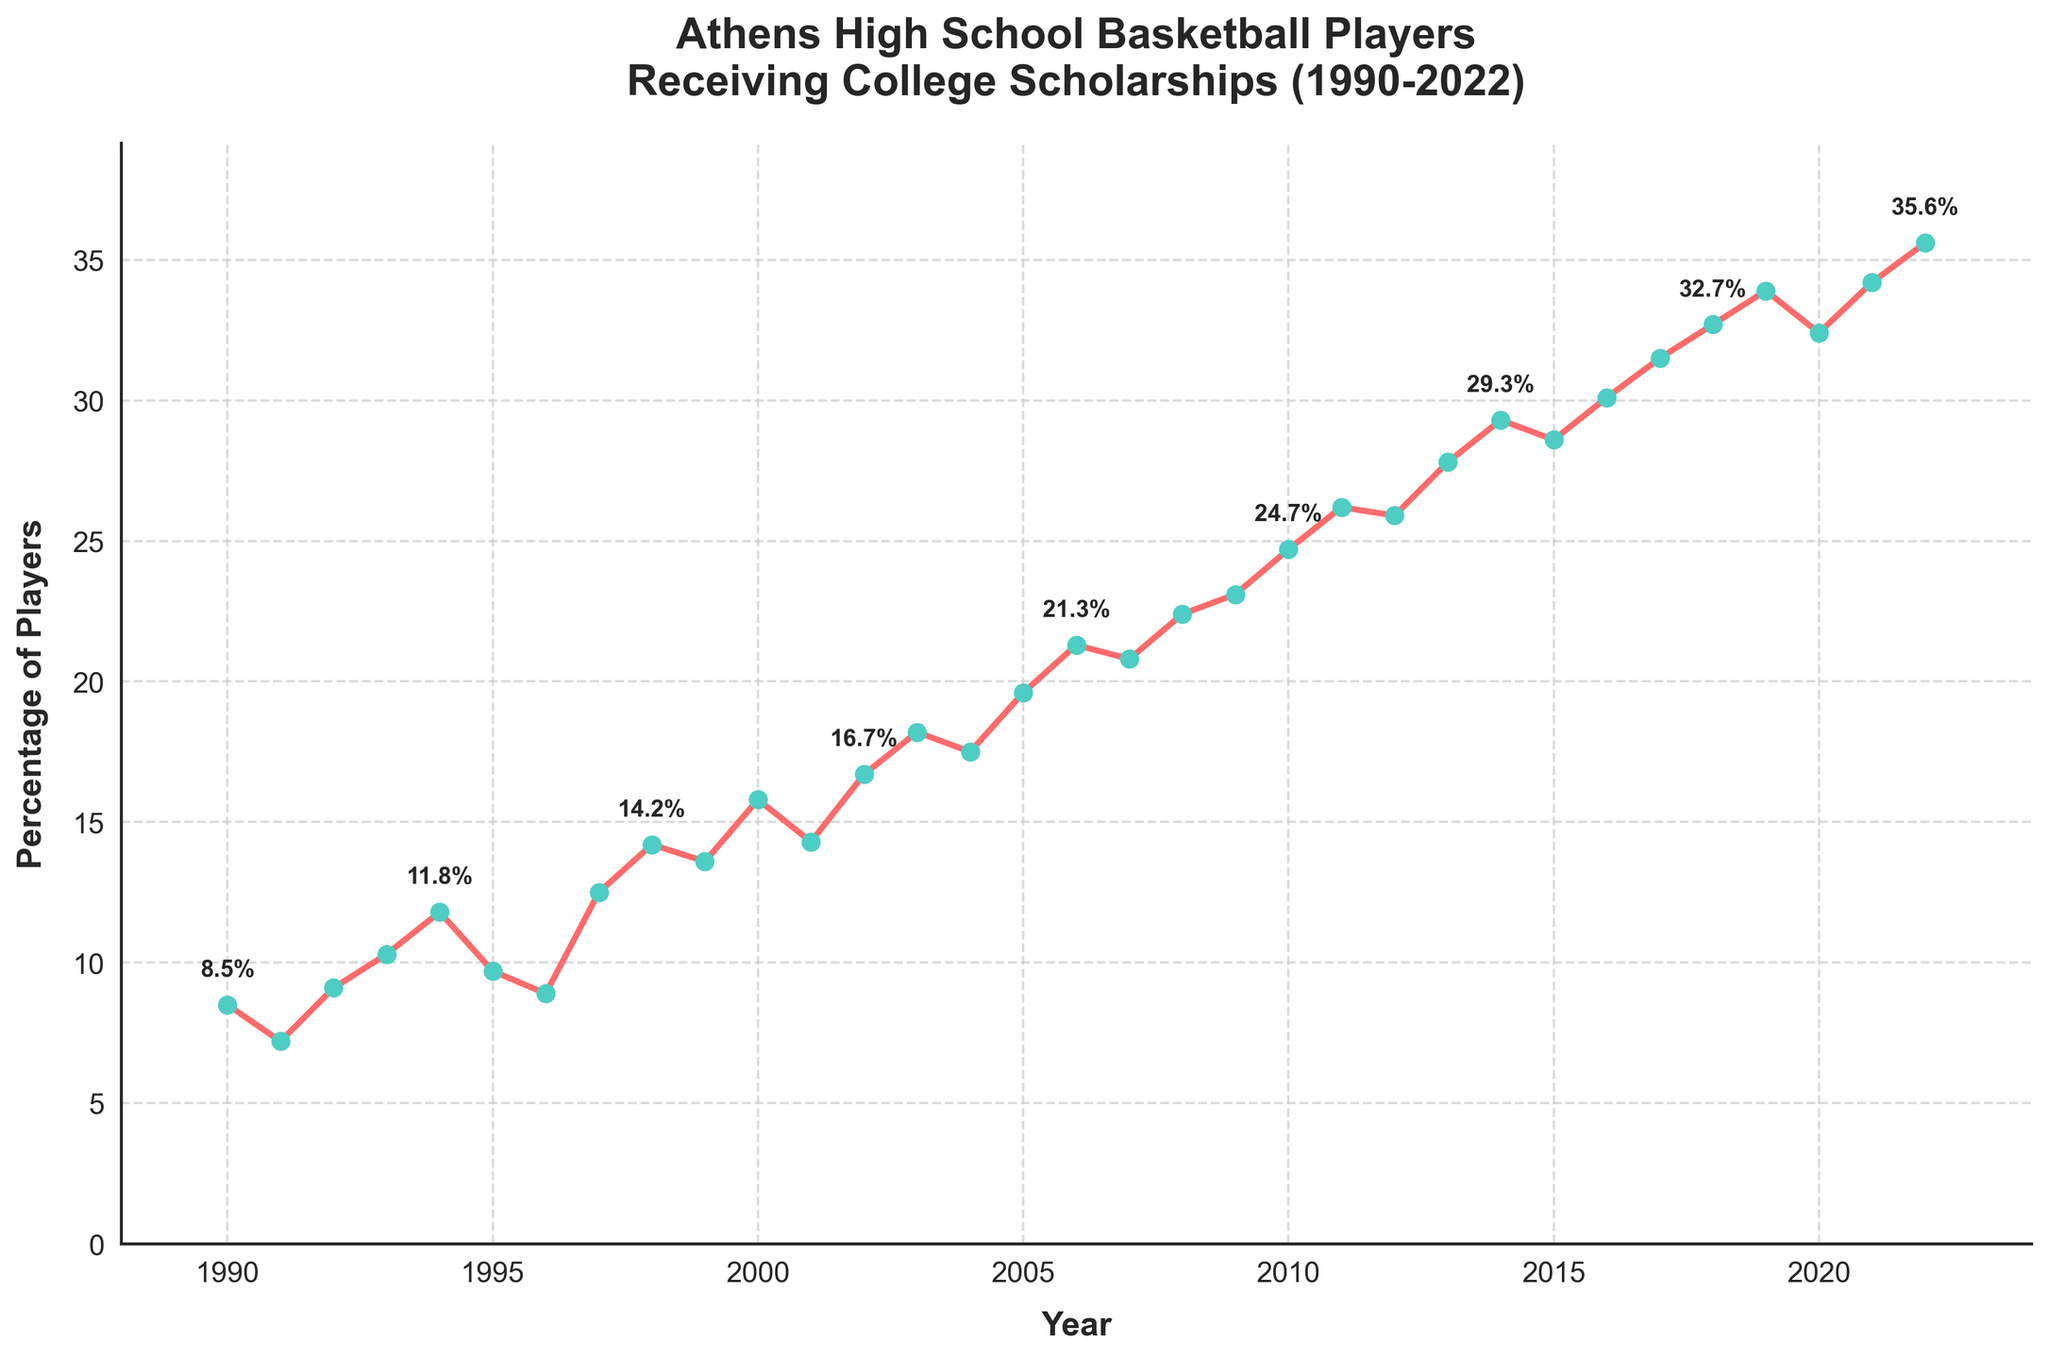What's the highest percentage of Athens High School basketball players receiving college scholarships? The highest percentage can be found by identifying the peak point on the line chart from 1990 to 2022. The peak point is in 2022, where the percentage is 35.6%.
Answer: 35.6% In which year did the percentage of scholarship recipients exceed 20% for the first time? To find when the percentage first exceeded 20%, scan the plot from left to right. In 2006, the percentage reached 21.3% for the first time.
Answer: 2006 What is the average percentage of scholarship recipients from 1990 to 2022? Add up all percentage values from 1990 to 2022, then divide by the number of years (33). \(\frac{8.5 + 7.2 + 9.1 + 10.3 + 11.8 + 9.7 + 8.9 + 12.5 + 14.2 + 13.6 + 15.8 + 14.3 + 16.7 + 18.2 + 17.5 + 19.6 + 21.3 + 20.8 + 22.4 + 23.1 + 24.7 + 26.2 + 25.9 + 27.8 + 29.3 + 28.6 + 30.1 + 31.5 + 32.7 + 33.9 + 32.4 + 34.2 + 35.6\) = 617.1, so 617.1 / 33 = 18.7%.
Answer: 18.7% Between 1990 and 2000, which year had the lowest percentage of players receiving scholarships? Review percentages from 1990 to 2000. The lowest percentage is in 1991 with 7.2%.
Answer: 1991 How many times did the percentage of scholarships decrease from one year to the next? Count the number of times the value decreases compared to the previous year. This occurs in 1991, 1995, 1996, 1999, 2004, 2012, 2015, and 2020—thus 8 times.
Answer: 8 Which year shows the greatest increase in the percentage of scholarship recipients compared to the previous year? Identify the largest change by calculating yearly differences: 
- 1991-1990: -1.3
- 1992-1991: +1.9
- 1993-1992: +1.2
- 1994-1993: +1.5
- 1995-1994: -2.1
- 1996-1995: -0.8 ...
- 2022-2021: +1.4
The largest increase is from 2010 to 2011 with +1.5.
Answer: 2011 What is the trend of the percentage of players receiving scholarships over the entire period? Examine the overall shape of the line from 1990 to 2022. The line shows a general upward trend, indicating an overall increase in the percentage of players receiving scholarships.
Answer: Increasing Compare the percentage of scholarships in 2002 and 2012. Which year had a higher percentage and by how much? From the chart, 2002 has 16.7%, and 2012 has 25.9%. Calculate the difference: 25.9 - 16.7 = 9.2%.
Answer: 2012 by 9.2% How much did the percentage of scholarship recipients decrease from 2020 to 2021? From the chart: 2020 had 32.4%, and 2021 had 34.2%. The percentage increased, so indicate by how much: 34.2 - 32.4 = 1.8%.
Answer: It increased by 1.8% 